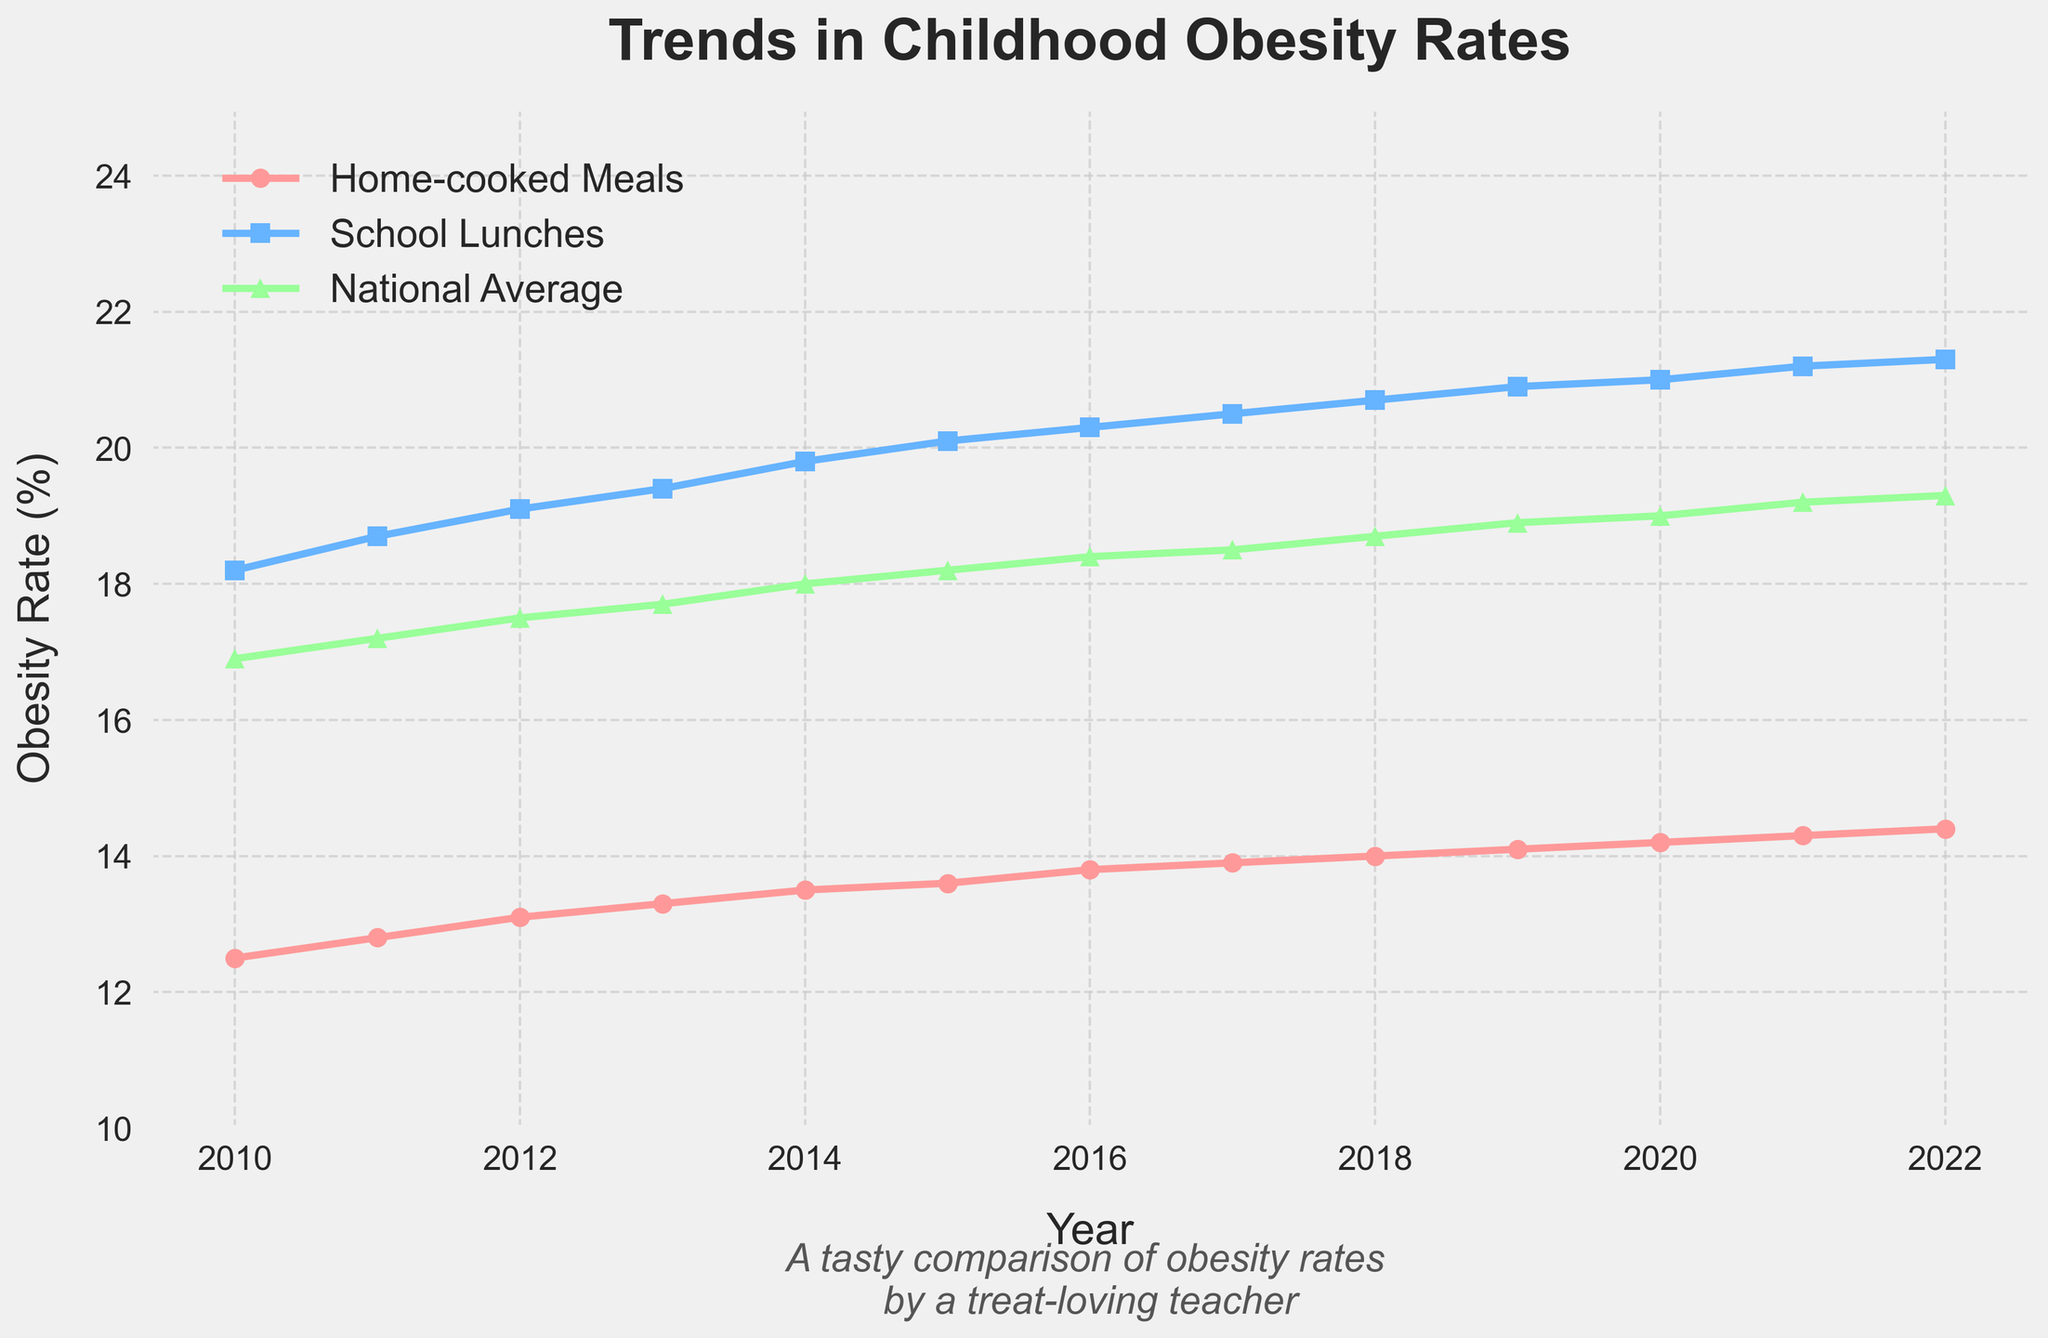What's the trend in obesity rates for students who eat home-cooked meals from 2010 to 2022? The line chart shows a gradual increase in the obesity rates for students who eat home-cooked meals. Starting at 12.5% in 2010, the rate increases almost every year, reaching 14.4% in 2022.
Answer: Gradual increase Which type of meals had the highest obesity rates throughout the years 2010 to 2022? By observing the plotted lines, the school lunches consistently have higher obesity rates compared to home-cooked meals and the national average for each year from 2010 to 2022.
Answer: School lunches By how much did the obesity rate for home-cooked meals increase from 2010 to 2022? To find the increase, subtract the 2010 obesity rate for home-cooked meals from the 2022 rate: 14.4% - 12.5% = 1.9%.
Answer: 1.9% In which year did the national average obesity rate surpass 19%? By examining the plotted line representing the national average, it is clear that the national average surpasses 19% in 2019 and continues to increase afterwards.
Answer: 2019 Compare the obesity rate trends of school lunches and home-cooked meals in 2013. In 2013, the obesity rate for school lunches is 19.4%, whereas for home-cooked meals, it is 13.3%. The difference between them is 19.4% - 13.3% = 6.1%.
Answer: School lunches higher by 6.1% Between 2015 and 2020, which data set experienced a more significant relative increase in obesity rates: home-cooked meals or school lunches? Calculate the relative increase by dividing the difference in obesity rates by the starting rate for each group. For home-cooked meals: (14.2% - 13.6%)/13.6% ≈ 0.0441 = 4.41%. For school lunches: (21.0% - 20.1%)/20.1% ≈ 0.0448 = 4.48%. School lunches experienced a slightly more significant relative increase.
Answer: School lunches By how much did the gap between the obesity rates of students eating school lunches and the national average change from 2010 to 2022? In 2010, the gap was 18.2% - 16.9% = 1.3%. In 2022, the gap was 21.3% - 19.3% = 2%. Therefore, the change in the gap is 2% - 1.3% = 0.7%.
Answer: Increased by 0.7% What can you say about the variance in the obesity rate in the home-cooked meals group compared to the national average group over the years 2010 to 2022? Both the home-cooked meals group and the national average group show an increasing trend, but the rate of increase for home-cooked meals is slower and the values are consistently lower than the national average. The deviation (or variance) between the two lines is generally quite small and stable.
Answer: Stable with a slower increase What was the obesity rate for the group with the highest rate in 2020? In 2020, the line for school lunches is the highest among the three groups, showing an obesity rate of 21.0%.
Answer: 21.0% Which group showed the most stability in obesity rates from 2010 to 2022 and how do you conclude that from the visual attributes of the plotted lines? The home-cooked meals group shows the most stability. This is evident from the relatively flat and consistent increase in the red line, which has fewer sharp changes compared to the other two lines.
Answer: Home-cooked meals 